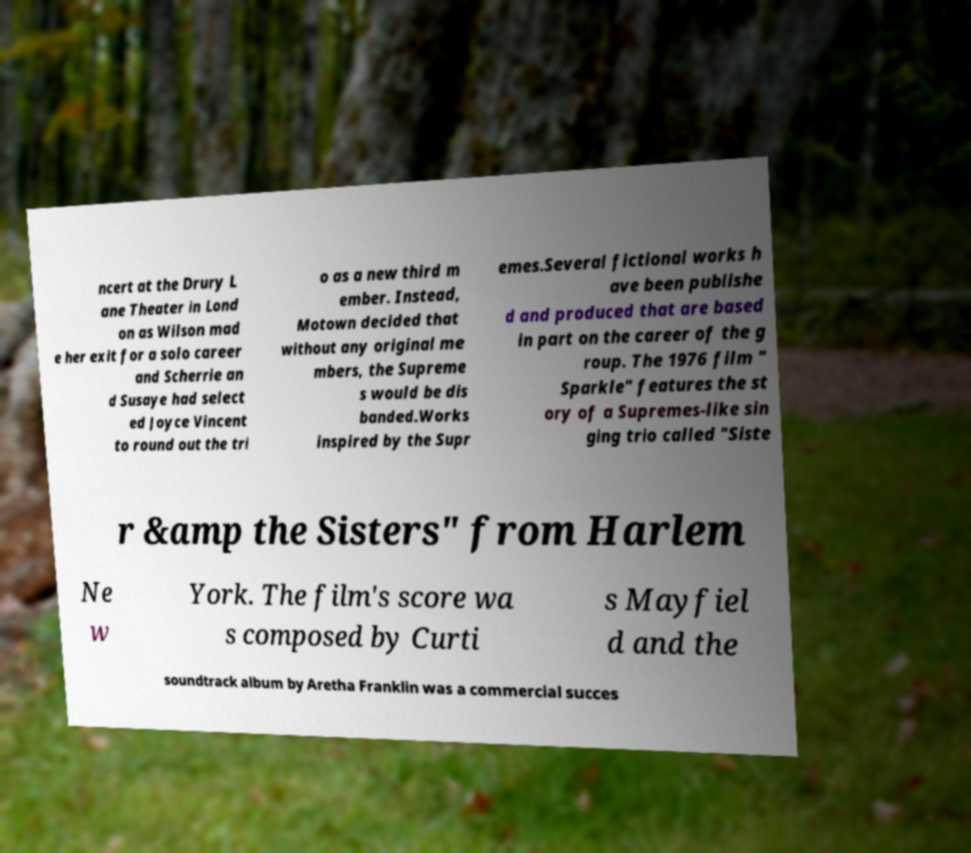Could you assist in decoding the text presented in this image and type it out clearly? ncert at the Drury L ane Theater in Lond on as Wilson mad e her exit for a solo career and Scherrie an d Susaye had select ed Joyce Vincent to round out the tri o as a new third m ember. Instead, Motown decided that without any original me mbers, the Supreme s would be dis banded.Works inspired by the Supr emes.Several fictional works h ave been publishe d and produced that are based in part on the career of the g roup. The 1976 film " Sparkle" features the st ory of a Supremes-like sin ging trio called "Siste r &amp the Sisters" from Harlem Ne w York. The film's score wa s composed by Curti s Mayfiel d and the soundtrack album by Aretha Franklin was a commercial succes 